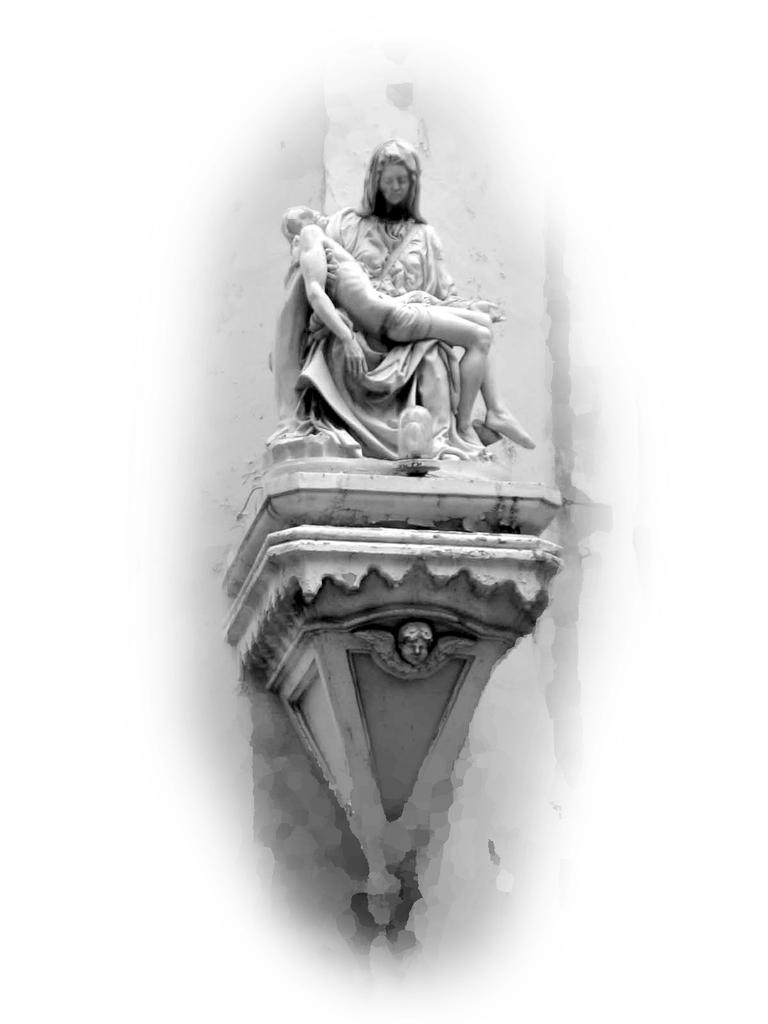What is the main subject of the image? There is a sculpture in the image. How many chickens are depicted in the sculpture? There is no chicken present in the image, as the main subject is a sculpture. 